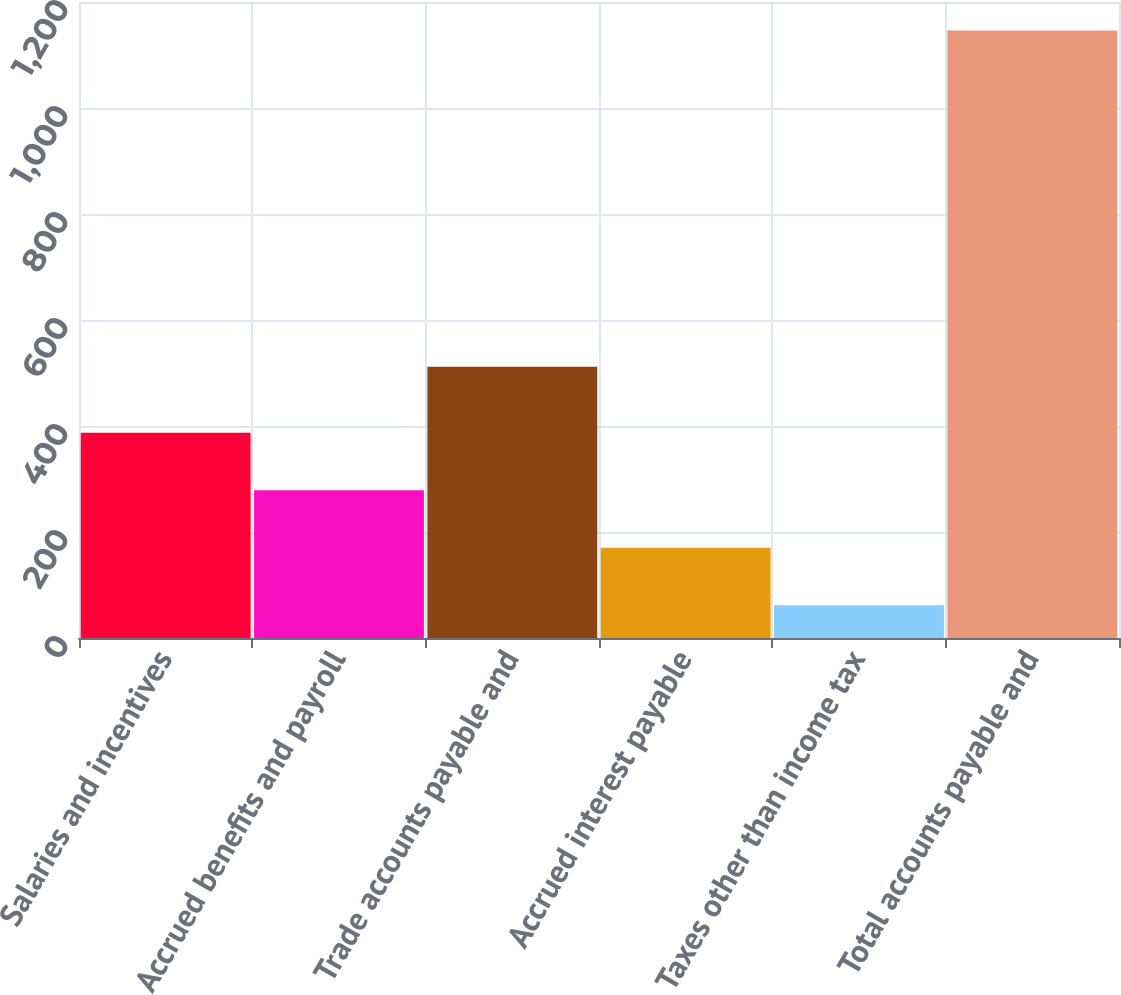Convert chart. <chart><loc_0><loc_0><loc_500><loc_500><bar_chart><fcel>Salaries and incentives<fcel>Accrued benefits and payroll<fcel>Trade accounts payable and<fcel>Accrued interest payable<fcel>Taxes other than income tax<fcel>Total accounts payable and<nl><fcel>387.2<fcel>278.8<fcel>512<fcel>170.4<fcel>62<fcel>1146<nl></chart> 